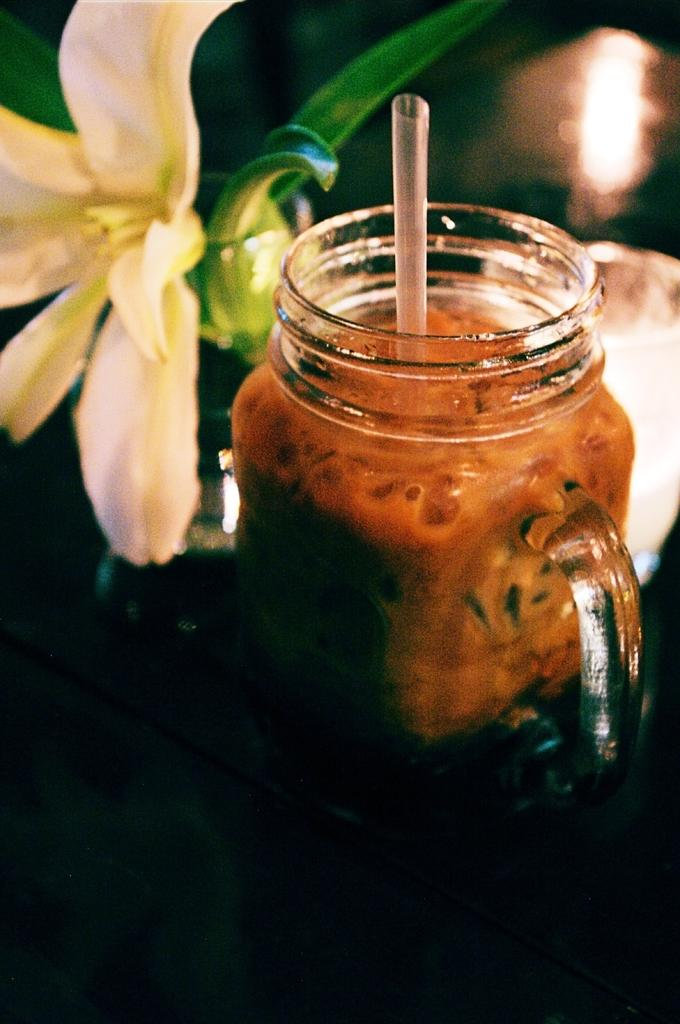What is inside the jar that is visible in the image? There is a jar with liquid in the image. How is the liquid being consumed in the image? There is a straw on the surface of the liquid, suggesting it is being used to drink the liquid. What can be seen at the bottom of the image? The bottom of the image has a dark view. What type of plant is visible in the background of the image? There is a flower in the background of the image. What other objects can be seen in the background of the image? There are other objects in the background of the image, but their specific details are not mentioned in the facts. What type of pipe is visible in the image? There is no pipe present in the image. How many passengers are visible in the image? There are no passengers present in the image. 